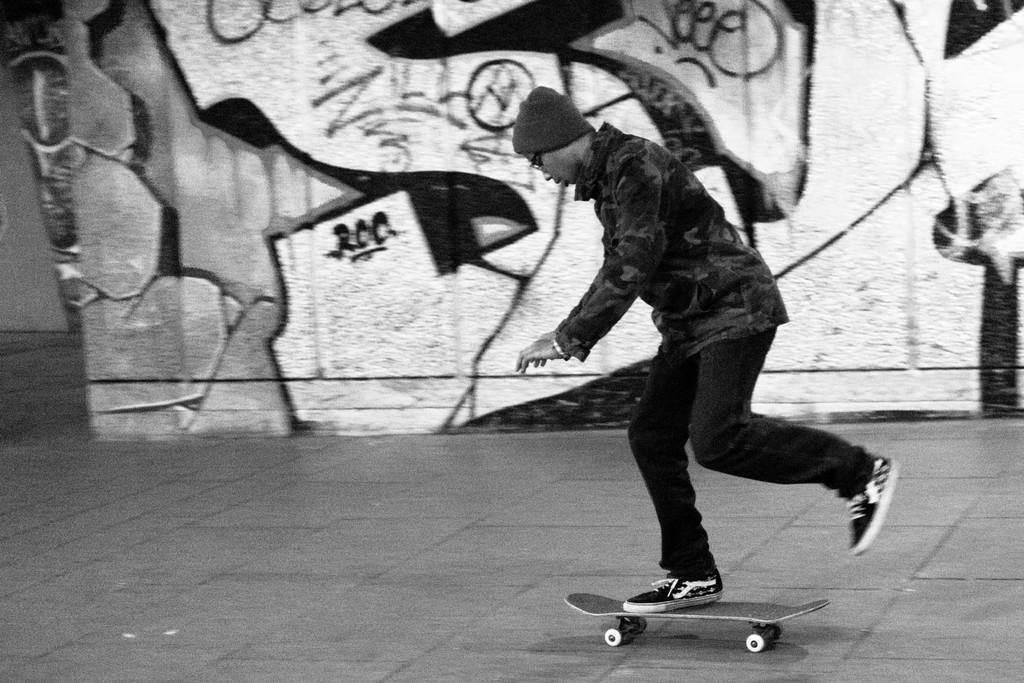Who or what is the main subject in the image? There is a person in the image. What is the person doing in the image? The person is on a skateboard. What type of surface can be seen beneath the person? There is ground visible in the image. What can be seen on the wall in the image? There is a wall with art in the image. What type of science experiment is being conducted on the plantation in the image? There is no science experiment or plantation present in the image; it features a person on a skateboard with a wall displaying art. What type of paper is being used to create the art on the wall in the image? There is no information about the materials used for the art on the wall in the image. 